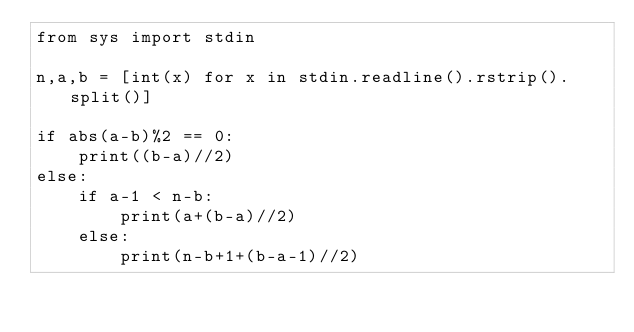Convert code to text. <code><loc_0><loc_0><loc_500><loc_500><_Python_>from sys import stdin

n,a,b = [int(x) for x in stdin.readline().rstrip().split()]

if abs(a-b)%2 == 0:
    print((b-a)//2)
else:
    if a-1 < n-b:
        print(a+(b-a)//2)
    else:
        print(n-b+1+(b-a-1)//2)</code> 